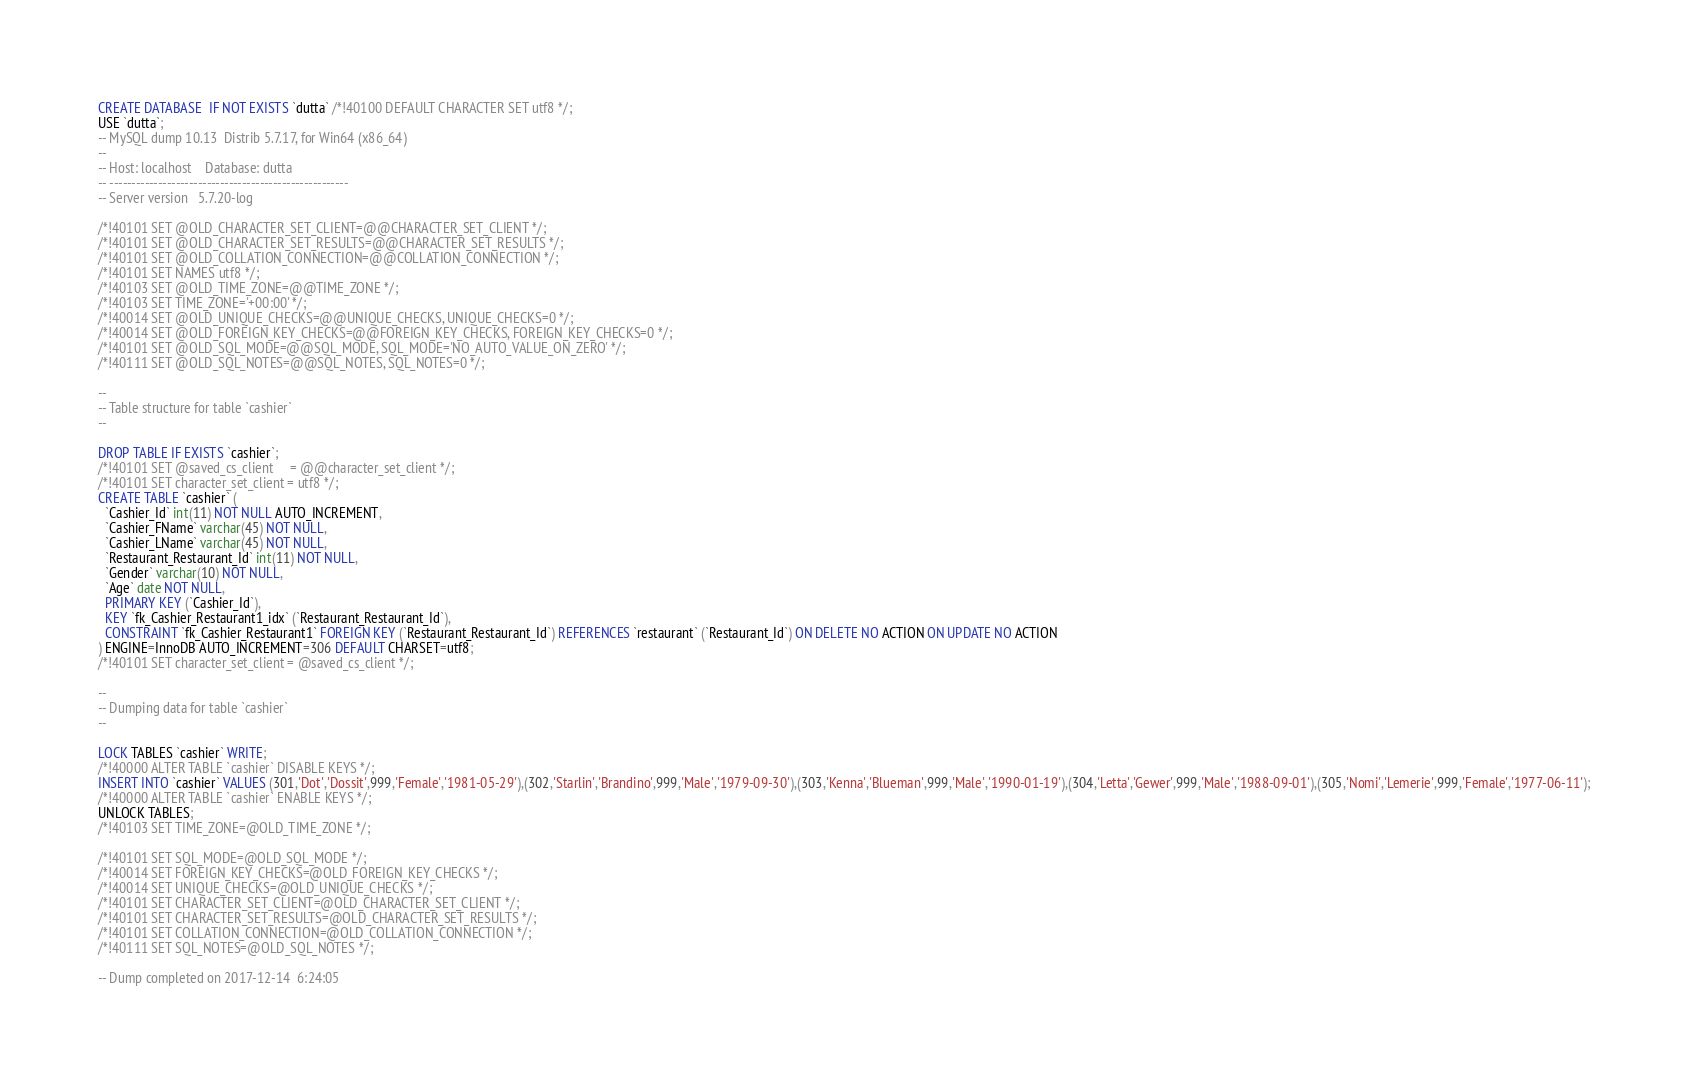Convert code to text. <code><loc_0><loc_0><loc_500><loc_500><_SQL_>CREATE DATABASE  IF NOT EXISTS `dutta` /*!40100 DEFAULT CHARACTER SET utf8 */;
USE `dutta`;
-- MySQL dump 10.13  Distrib 5.7.17, for Win64 (x86_64)
--
-- Host: localhost    Database: dutta
-- ------------------------------------------------------
-- Server version	5.7.20-log

/*!40101 SET @OLD_CHARACTER_SET_CLIENT=@@CHARACTER_SET_CLIENT */;
/*!40101 SET @OLD_CHARACTER_SET_RESULTS=@@CHARACTER_SET_RESULTS */;
/*!40101 SET @OLD_COLLATION_CONNECTION=@@COLLATION_CONNECTION */;
/*!40101 SET NAMES utf8 */;
/*!40103 SET @OLD_TIME_ZONE=@@TIME_ZONE */;
/*!40103 SET TIME_ZONE='+00:00' */;
/*!40014 SET @OLD_UNIQUE_CHECKS=@@UNIQUE_CHECKS, UNIQUE_CHECKS=0 */;
/*!40014 SET @OLD_FOREIGN_KEY_CHECKS=@@FOREIGN_KEY_CHECKS, FOREIGN_KEY_CHECKS=0 */;
/*!40101 SET @OLD_SQL_MODE=@@SQL_MODE, SQL_MODE='NO_AUTO_VALUE_ON_ZERO' */;
/*!40111 SET @OLD_SQL_NOTES=@@SQL_NOTES, SQL_NOTES=0 */;

--
-- Table structure for table `cashier`
--

DROP TABLE IF EXISTS `cashier`;
/*!40101 SET @saved_cs_client     = @@character_set_client */;
/*!40101 SET character_set_client = utf8 */;
CREATE TABLE `cashier` (
  `Cashier_Id` int(11) NOT NULL AUTO_INCREMENT,
  `Cashier_FName` varchar(45) NOT NULL,
  `Cashier_LName` varchar(45) NOT NULL,
  `Restaurant_Restaurant_Id` int(11) NOT NULL,
  `Gender` varchar(10) NOT NULL,
  `Age` date NOT NULL,
  PRIMARY KEY (`Cashier_Id`),
  KEY `fk_Cashier_Restaurant1_idx` (`Restaurant_Restaurant_Id`),
  CONSTRAINT `fk_Cashier_Restaurant1` FOREIGN KEY (`Restaurant_Restaurant_Id`) REFERENCES `restaurant` (`Restaurant_Id`) ON DELETE NO ACTION ON UPDATE NO ACTION
) ENGINE=InnoDB AUTO_INCREMENT=306 DEFAULT CHARSET=utf8;
/*!40101 SET character_set_client = @saved_cs_client */;

--
-- Dumping data for table `cashier`
--

LOCK TABLES `cashier` WRITE;
/*!40000 ALTER TABLE `cashier` DISABLE KEYS */;
INSERT INTO `cashier` VALUES (301,'Dot','Dossit',999,'Female','1981-05-29'),(302,'Starlin','Brandino',999,'Male','1979-09-30'),(303,'Kenna','Blueman',999,'Male','1990-01-19'),(304,'Letta','Gewer',999,'Male','1988-09-01'),(305,'Nomi','Lemerie',999,'Female','1977-06-11');
/*!40000 ALTER TABLE `cashier` ENABLE KEYS */;
UNLOCK TABLES;
/*!40103 SET TIME_ZONE=@OLD_TIME_ZONE */;

/*!40101 SET SQL_MODE=@OLD_SQL_MODE */;
/*!40014 SET FOREIGN_KEY_CHECKS=@OLD_FOREIGN_KEY_CHECKS */;
/*!40014 SET UNIQUE_CHECKS=@OLD_UNIQUE_CHECKS */;
/*!40101 SET CHARACTER_SET_CLIENT=@OLD_CHARACTER_SET_CLIENT */;
/*!40101 SET CHARACTER_SET_RESULTS=@OLD_CHARACTER_SET_RESULTS */;
/*!40101 SET COLLATION_CONNECTION=@OLD_COLLATION_CONNECTION */;
/*!40111 SET SQL_NOTES=@OLD_SQL_NOTES */;

-- Dump completed on 2017-12-14  6:24:05
</code> 